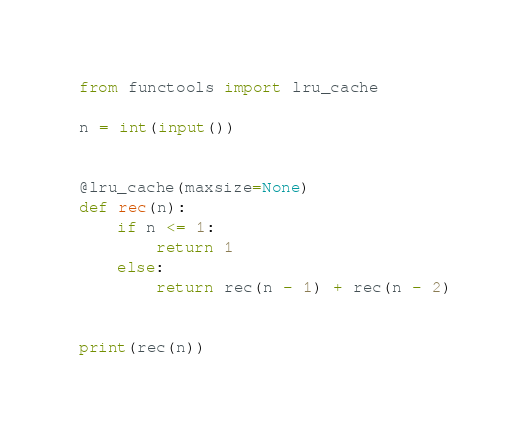Convert code to text. <code><loc_0><loc_0><loc_500><loc_500><_Python_>from functools import lru_cache

n = int(input())


@lru_cache(maxsize=None)
def rec(n):
    if n <= 1:
        return 1
    else:
        return rec(n - 1) + rec(n - 2)


print(rec(n))
</code> 